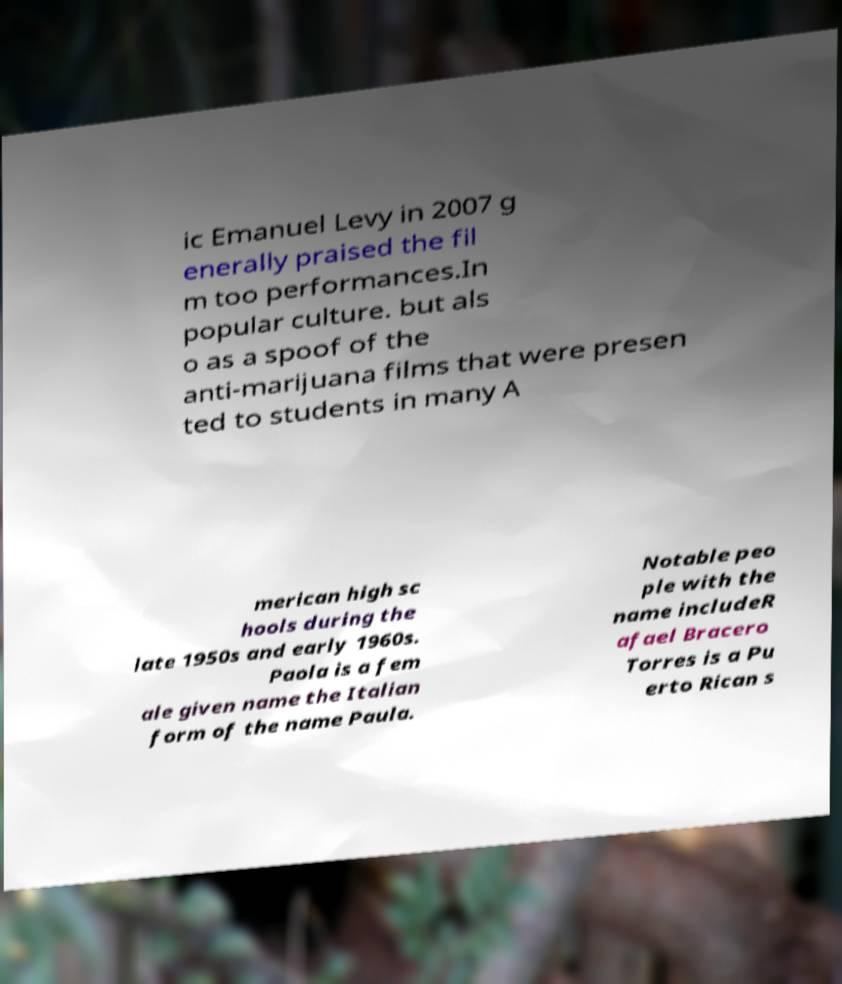I need the written content from this picture converted into text. Can you do that? ic Emanuel Levy in 2007 g enerally praised the fil m too performances.In popular culture. but als o as a spoof of the anti-marijuana films that were presen ted to students in many A merican high sc hools during the late 1950s and early 1960s. Paola is a fem ale given name the Italian form of the name Paula. Notable peo ple with the name includeR afael Bracero Torres is a Pu erto Rican s 